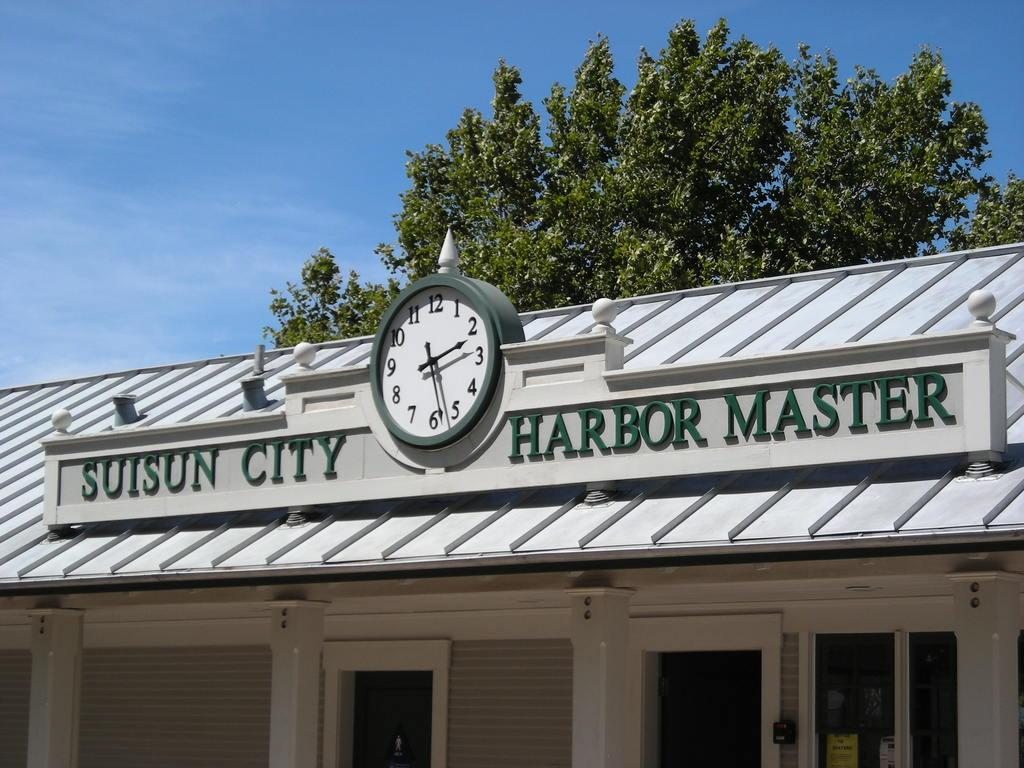Provide a one-sentence caption for the provided image. Suisun City Harbor Master building with a clock in the middle. 